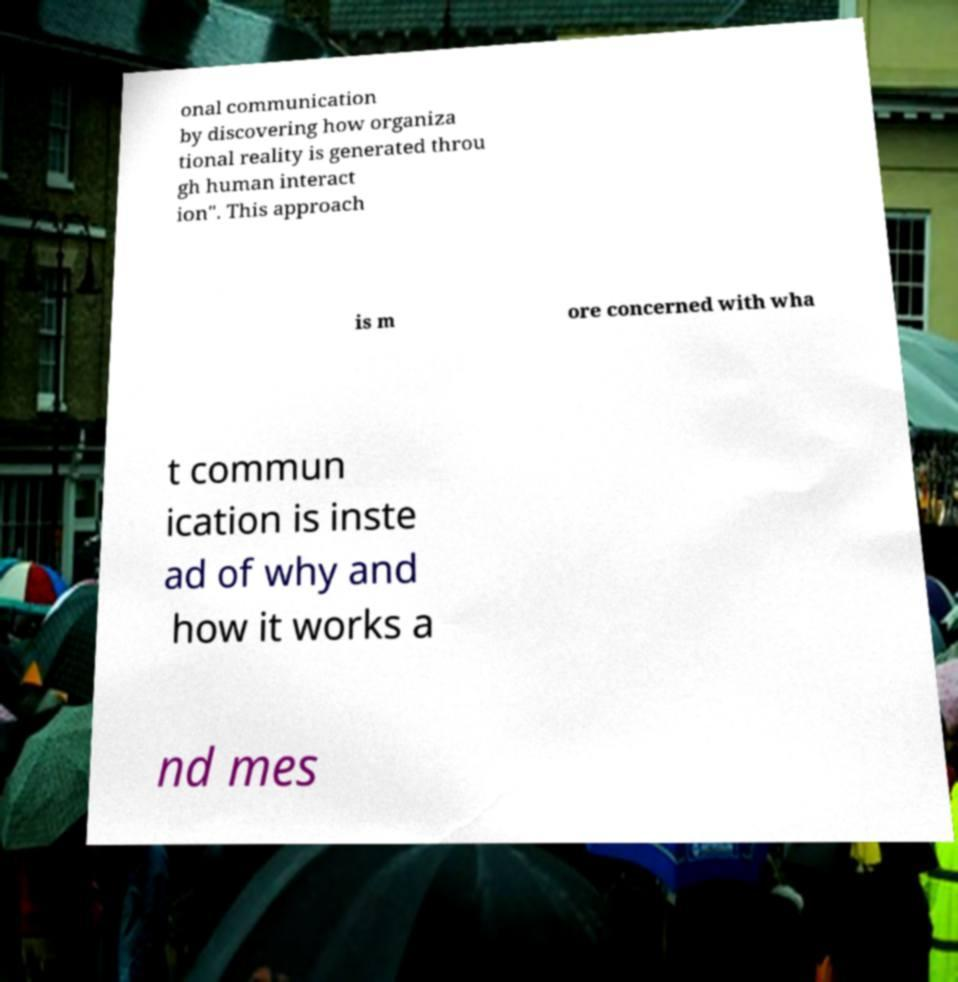Can you accurately transcribe the text from the provided image for me? onal communication by discovering how organiza tional reality is generated throu gh human interact ion". This approach is m ore concerned with wha t commun ication is inste ad of why and how it works a nd mes 